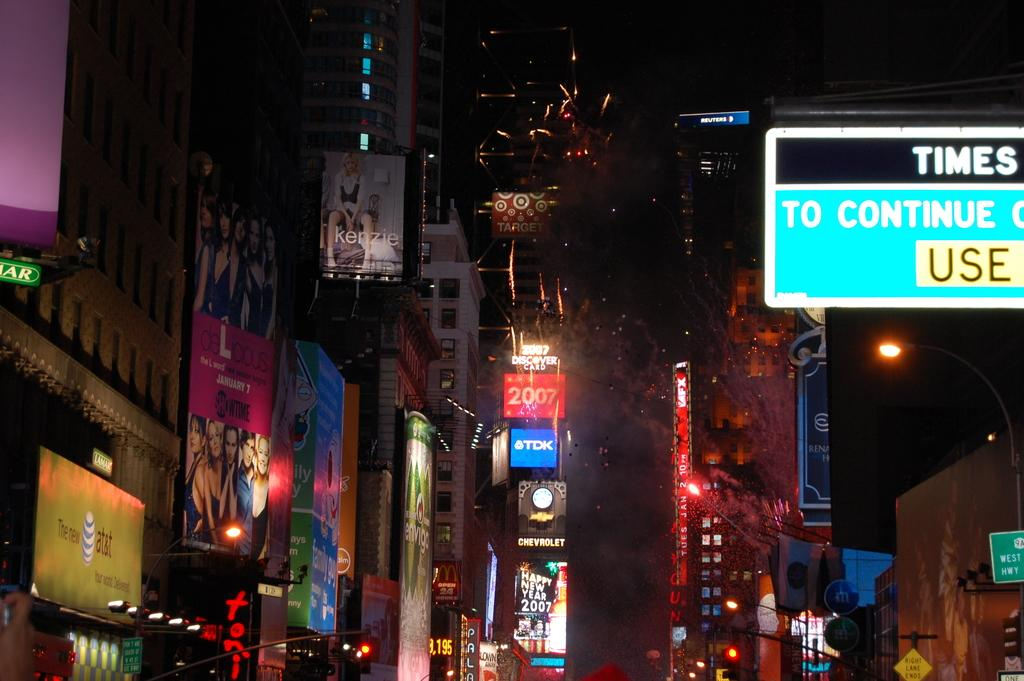Where was the picture taken? The picture was taken outside. What can be seen on the banners in the image? The banners have text and pictures of persons in the image. What type of structures can be seen in the background of the image? There are buildings visible in the image. What is used to illuminate the scene in the image? Lights are present in the image. Can you describe any other objects or features in the image? There are other unspecified objects in the image. What type of apparel is the clock wearing in the image? There is no clock present in the image, so it is not possible to determine what type of apparel it might be wearing. 